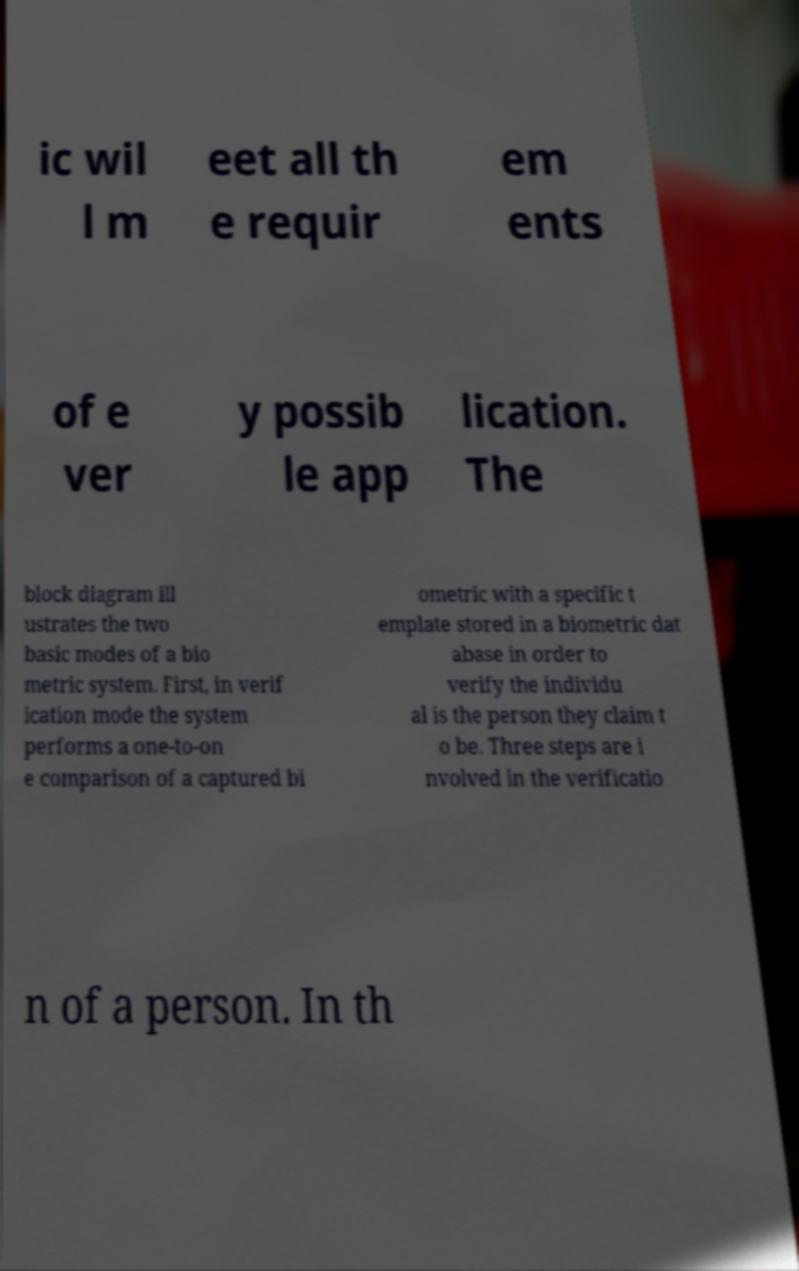For documentation purposes, I need the text within this image transcribed. Could you provide that? ic wil l m eet all th e requir em ents of e ver y possib le app lication. The block diagram ill ustrates the two basic modes of a bio metric system. First, in verif ication mode the system performs a one-to-on e comparison of a captured bi ometric with a specific t emplate stored in a biometric dat abase in order to verify the individu al is the person they claim t o be. Three steps are i nvolved in the verificatio n of a person. In th 